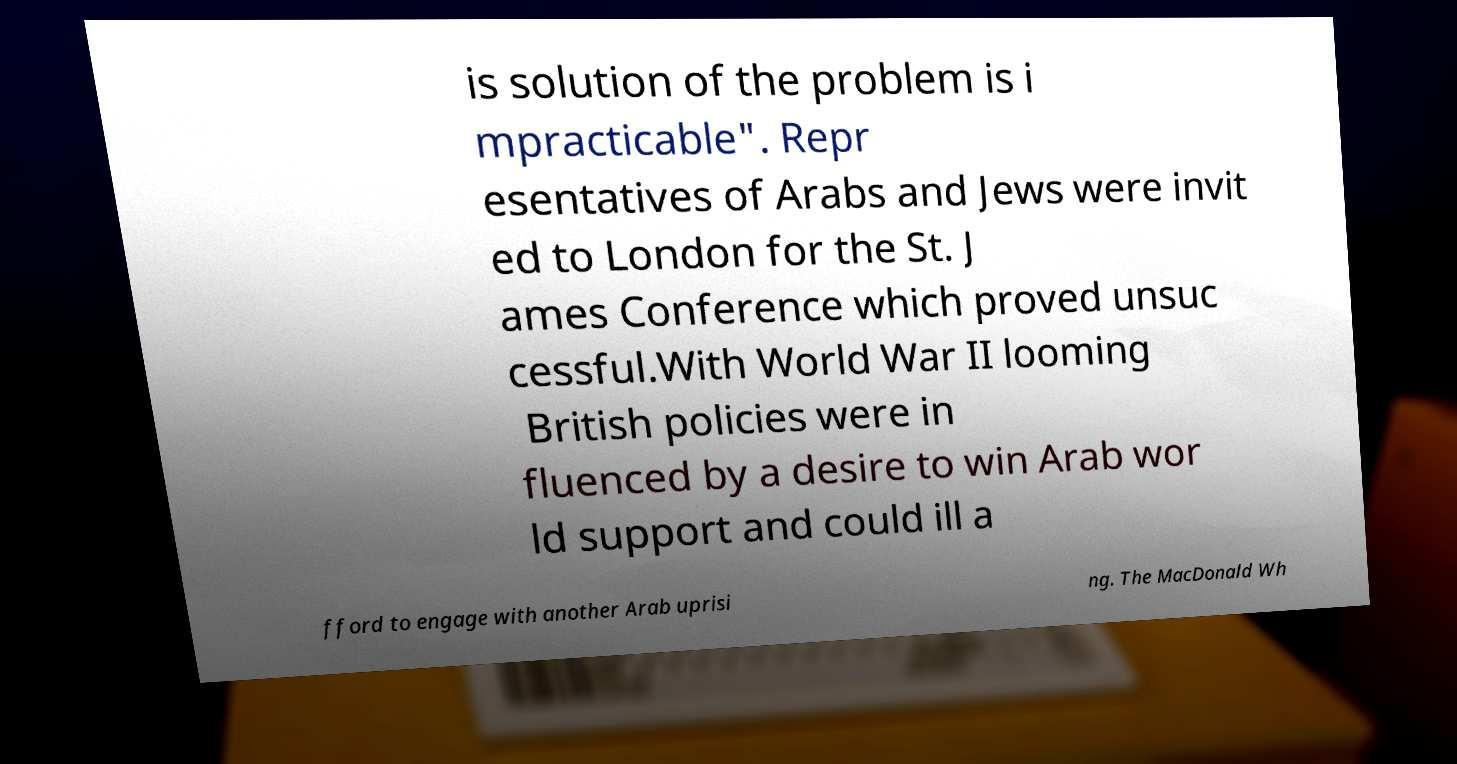For documentation purposes, I need the text within this image transcribed. Could you provide that? is solution of the problem is i mpracticable". Repr esentatives of Arabs and Jews were invit ed to London for the St. J ames Conference which proved unsuc cessful.With World War II looming British policies were in fluenced by a desire to win Arab wor ld support and could ill a fford to engage with another Arab uprisi ng. The MacDonald Wh 